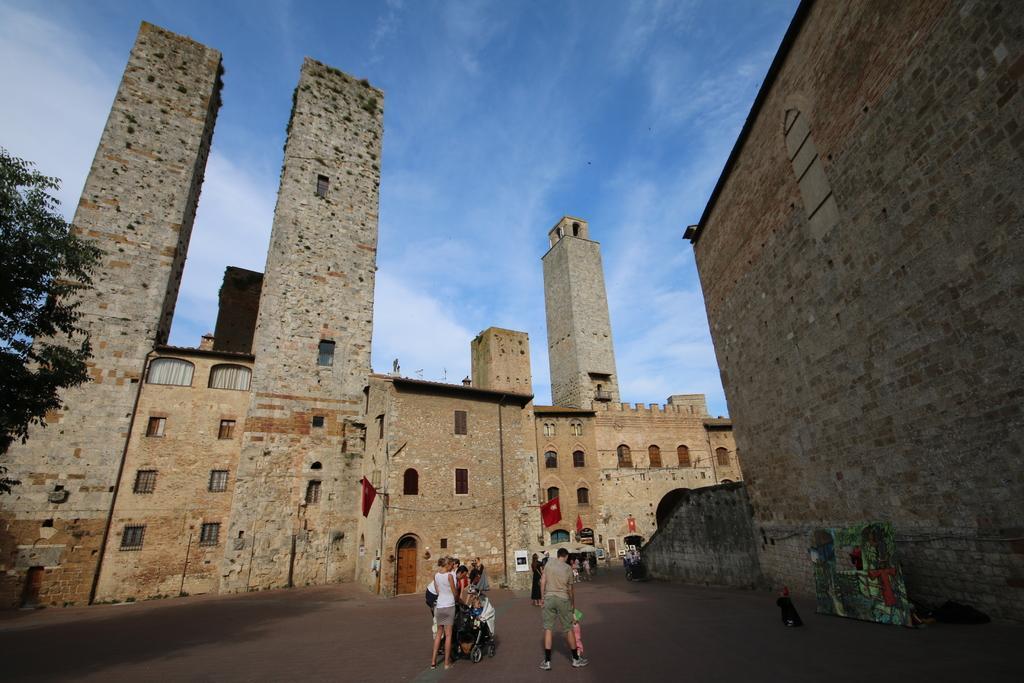How would you summarize this image in a sentence or two? In this image I can see group of people standing on the road. Background I can see few buildings in brown color and few flags in red color, trees in green color and sky in blue color. 